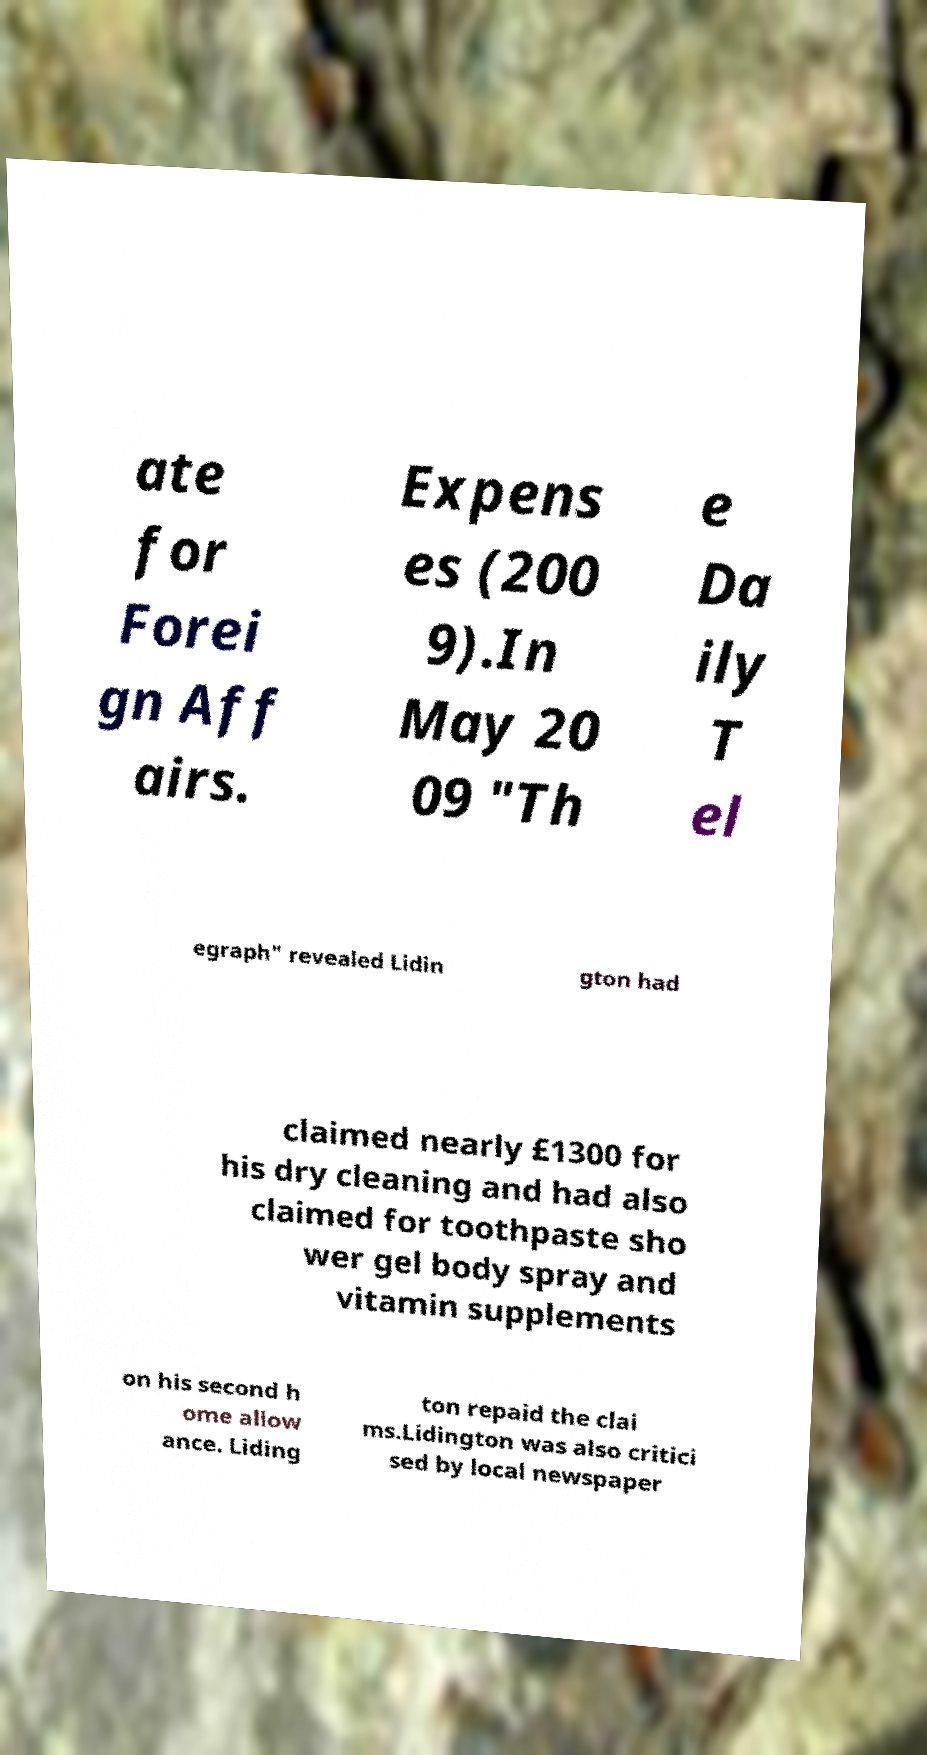For documentation purposes, I need the text within this image transcribed. Could you provide that? ate for Forei gn Aff airs. Expens es (200 9).In May 20 09 "Th e Da ily T el egraph" revealed Lidin gton had claimed nearly £1300 for his dry cleaning and had also claimed for toothpaste sho wer gel body spray and vitamin supplements on his second h ome allow ance. Liding ton repaid the clai ms.Lidington was also critici sed by local newspaper 